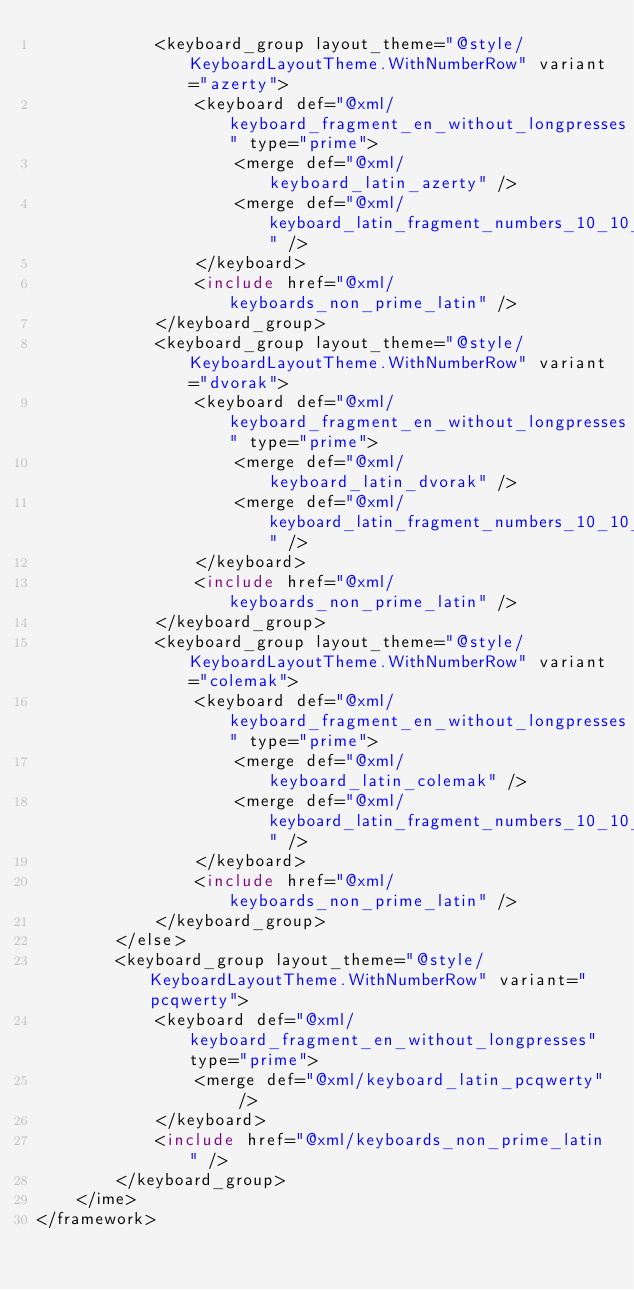<code> <loc_0><loc_0><loc_500><loc_500><_XML_>            <keyboard_group layout_theme="@style/KeyboardLayoutTheme.WithNumberRow" variant="azerty">
                <keyboard def="@xml/keyboard_fragment_en_without_longpresses" type="prime">
                    <merge def="@xml/keyboard_latin_azerty" />
                    <merge def="@xml/keyboard_latin_fragment_numbers_10_10_10_9" />
                </keyboard>
                <include href="@xml/keyboards_non_prime_latin" />
            </keyboard_group>
            <keyboard_group layout_theme="@style/KeyboardLayoutTheme.WithNumberRow" variant="dvorak">
                <keyboard def="@xml/keyboard_fragment_en_without_longpresses" type="prime">
                    <merge def="@xml/keyboard_latin_dvorak" />
                    <merge def="@xml/keyboard_latin_fragment_numbers_10_10_10_9" />
                </keyboard>
                <include href="@xml/keyboards_non_prime_latin" />
            </keyboard_group>
            <keyboard_group layout_theme="@style/KeyboardLayoutTheme.WithNumberRow" variant="colemak">
                <keyboard def="@xml/keyboard_fragment_en_without_longpresses" type="prime">
                    <merge def="@xml/keyboard_latin_colemak" />
                    <merge def="@xml/keyboard_latin_fragment_numbers_10_10_10_9" />
                </keyboard>
                <include href="@xml/keyboards_non_prime_latin" />
            </keyboard_group>
        </else>
        <keyboard_group layout_theme="@style/KeyboardLayoutTheme.WithNumberRow" variant="pcqwerty">
            <keyboard def="@xml/keyboard_fragment_en_without_longpresses" type="prime">
                <merge def="@xml/keyboard_latin_pcqwerty" />
            </keyboard>
            <include href="@xml/keyboards_non_prime_latin" />
        </keyboard_group>
    </ime>
</framework></code> 